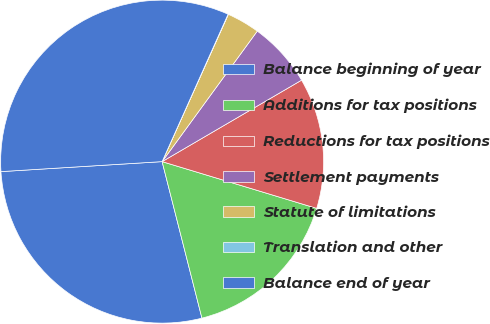Convert chart. <chart><loc_0><loc_0><loc_500><loc_500><pie_chart><fcel>Balance beginning of year<fcel>Additions for tax positions<fcel>Reductions for tax positions<fcel>Settlement payments<fcel>Statute of limitations<fcel>Translation and other<fcel>Balance end of year<nl><fcel>27.98%<fcel>16.36%<fcel>13.09%<fcel>6.56%<fcel>3.3%<fcel>0.03%<fcel>32.68%<nl></chart> 